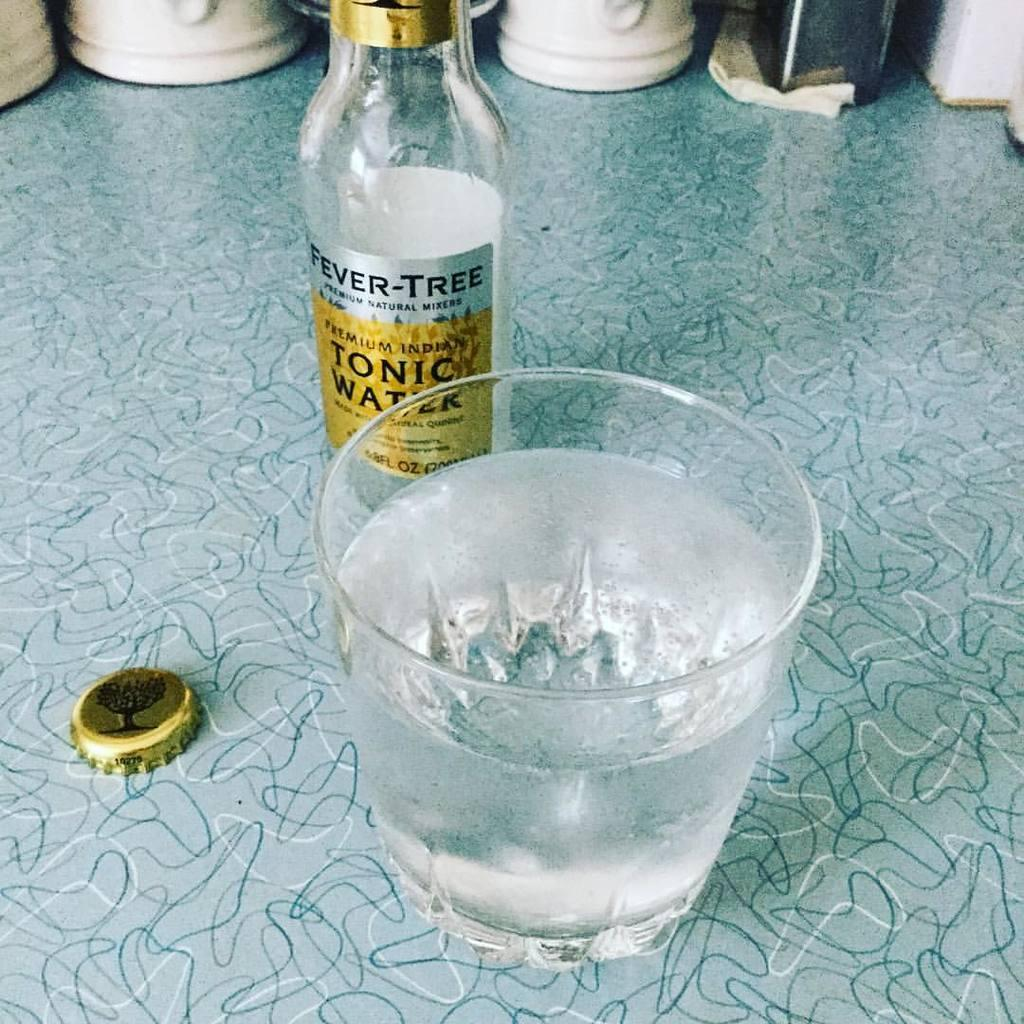<image>
Summarize the visual content of the image. A bottle of tonic water behind a glass of water. 